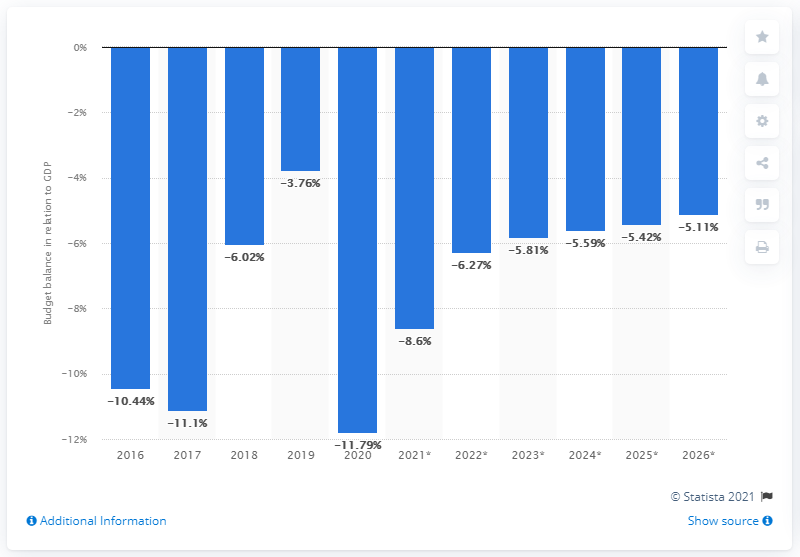Mention a couple of crucial points in this snapshot. Trinidad and Tobago's budget balance last related to GDP in 2020. 